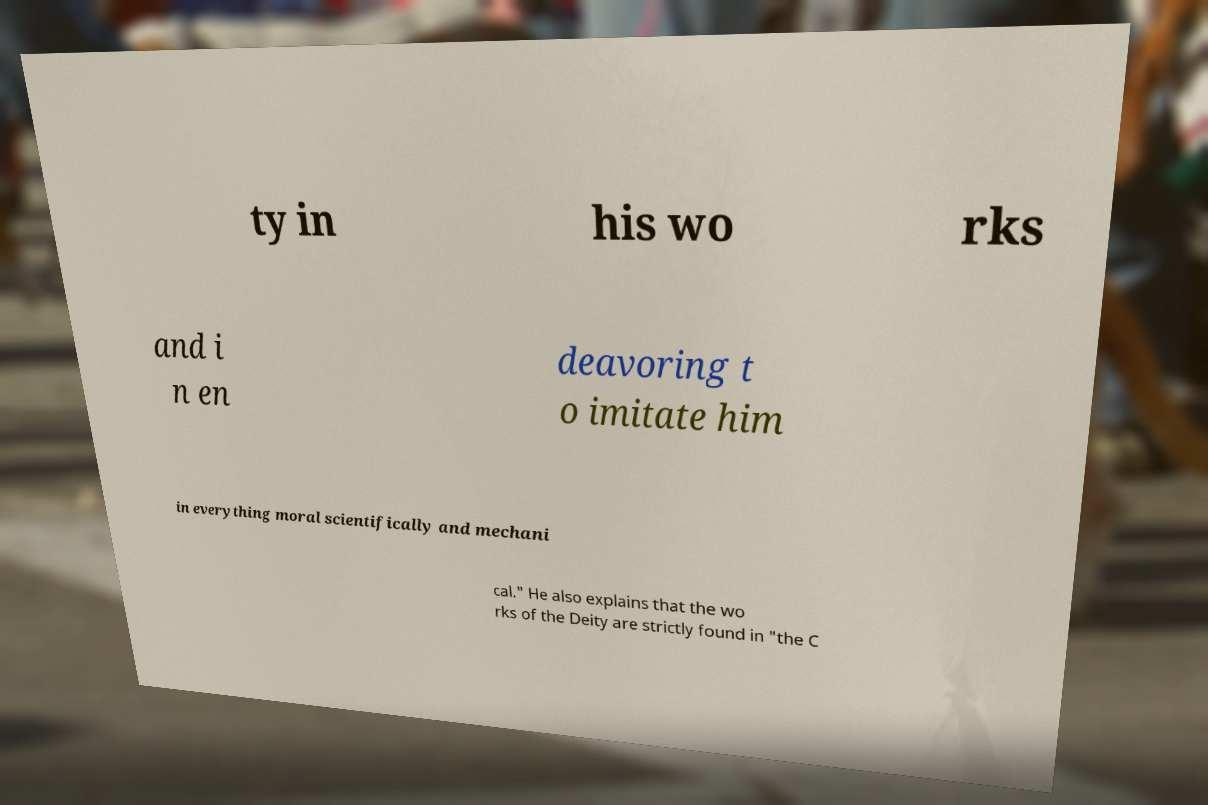Please read and relay the text visible in this image. What does it say? ty in his wo rks and i n en deavoring t o imitate him in everything moral scientifically and mechani cal." He also explains that the wo rks of the Deity are strictly found in "the C 